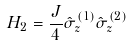Convert formula to latex. <formula><loc_0><loc_0><loc_500><loc_500>H _ { 2 } = \frac { J } { 4 } \hat { \sigma } _ { z } ^ { ( 1 ) } \hat { \sigma } _ { z } ^ { ( 2 ) }</formula> 